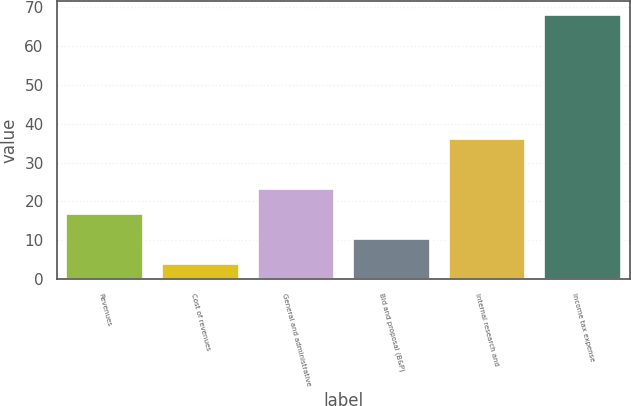<chart> <loc_0><loc_0><loc_500><loc_500><bar_chart><fcel>Revenues<fcel>Cost of revenues<fcel>General and administrative<fcel>Bid and proposal (B&P)<fcel>Internal research and<fcel>Income tax expense<nl><fcel>16.8<fcel>4<fcel>23.2<fcel>10.4<fcel>36<fcel>68<nl></chart> 